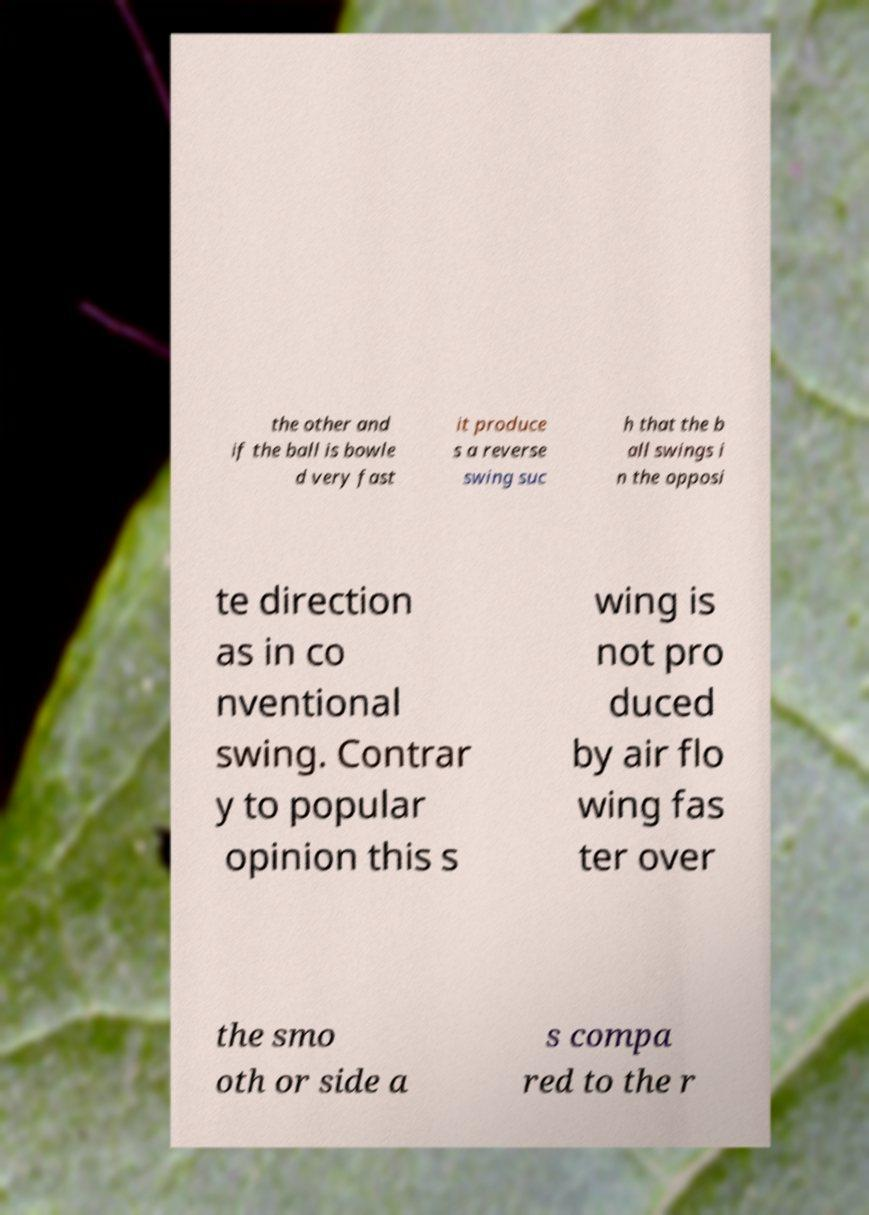Please identify and transcribe the text found in this image. the other and if the ball is bowle d very fast it produce s a reverse swing suc h that the b all swings i n the opposi te direction as in co nventional swing. Contrar y to popular opinion this s wing is not pro duced by air flo wing fas ter over the smo oth or side a s compa red to the r 